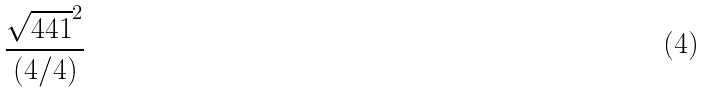Convert formula to latex. <formula><loc_0><loc_0><loc_500><loc_500>\frac { \sqrt { 4 4 1 } ^ { 2 } } { ( 4 / 4 ) }</formula> 